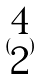Convert formula to latex. <formula><loc_0><loc_0><loc_500><loc_500>( \begin{matrix} 4 \\ 2 \end{matrix} )</formula> 